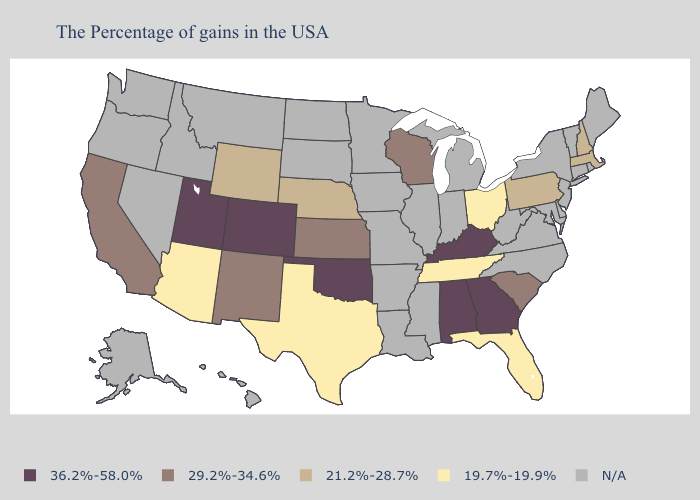What is the highest value in states that border Maine?
Answer briefly. 21.2%-28.7%. What is the lowest value in states that border South Dakota?
Quick response, please. 21.2%-28.7%. How many symbols are there in the legend?
Quick response, please. 5. Name the states that have a value in the range 21.2%-28.7%?
Short answer required. Massachusetts, New Hampshire, Pennsylvania, Nebraska, Wyoming. How many symbols are there in the legend?
Keep it brief. 5. Name the states that have a value in the range 29.2%-34.6%?
Short answer required. South Carolina, Wisconsin, Kansas, New Mexico, California. What is the value of Louisiana?
Be succinct. N/A. What is the value of South Dakota?
Short answer required. N/A. What is the value of Georgia?
Quick response, please. 36.2%-58.0%. Among the states that border Arizona , does Colorado have the highest value?
Give a very brief answer. Yes. What is the highest value in the South ?
Short answer required. 36.2%-58.0%. Does the map have missing data?
Concise answer only. Yes. Does Oklahoma have the lowest value in the USA?
Give a very brief answer. No. 